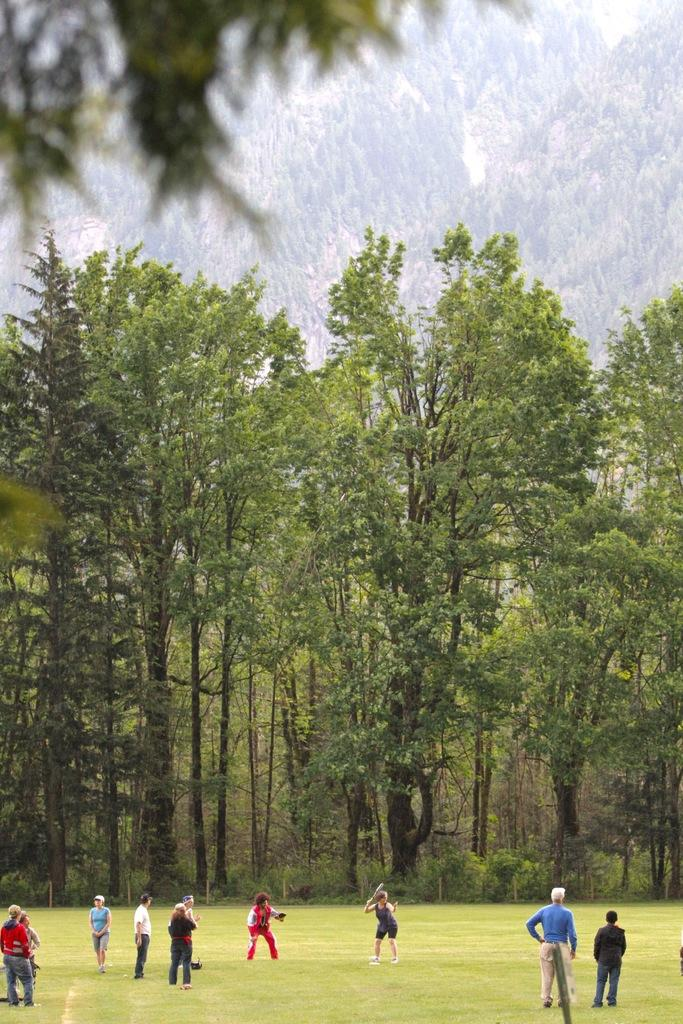What are the people in the image doing? The people in the image are playing. Where are the people playing? The people are playing on a grassy land. What can be seen in the background of the image? There are trees in the background of the image. What type of scissors can be seen in the image? There are no scissors present in the image. How many bodies are visible in the image? The term "body" is not relevant to the image, as it features people playing, not individual body parts. 